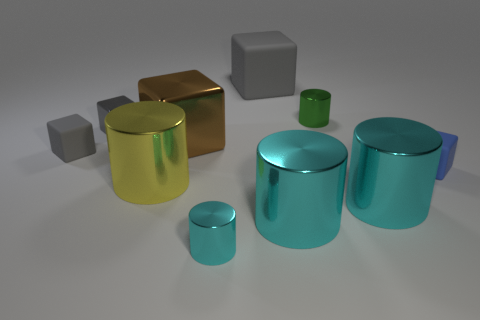There is a brown object to the right of the yellow metal thing; what is its shape? cube 